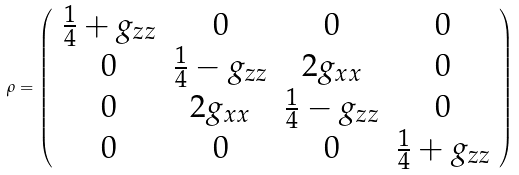<formula> <loc_0><loc_0><loc_500><loc_500>\rho = \left ( \begin{array} { c c c c } \frac { 1 } { 4 } + g _ { z z } & 0 & 0 & 0 \\ 0 & \frac { 1 } { 4 } - g _ { z z } & 2 g _ { x x } & 0 \\ 0 & 2 g _ { x x } & \frac { 1 } { 4 } - g _ { z z } & 0 \\ 0 & 0 & 0 & \frac { 1 } { 4 } + g _ { z z } \end{array} \right )</formula> 